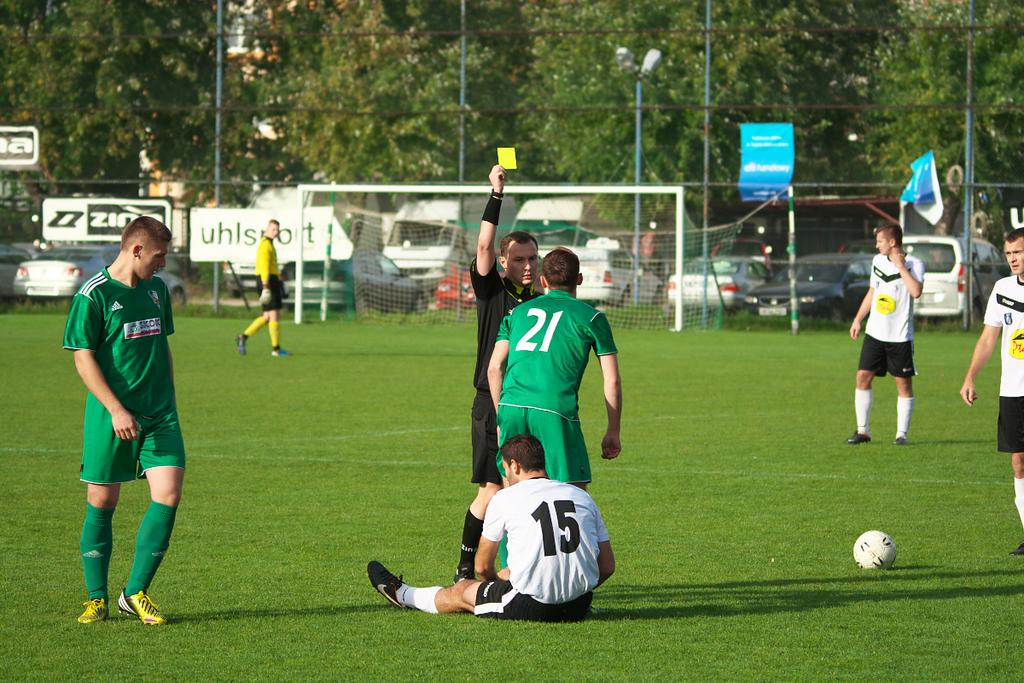<image>
Write a terse but informative summary of the picture. A player wearing green Jersey number '21' receives a yellow card during a soccer game on the field. 